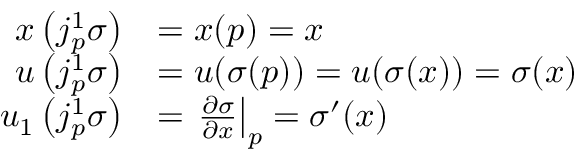<formula> <loc_0><loc_0><loc_500><loc_500>{ \begin{array} { r l } { x \left ( j _ { p } ^ { 1 } \sigma \right ) } & { = x ( p ) = x } \\ { u \left ( j _ { p } ^ { 1 } \sigma \right ) } & { = u ( \sigma ( p ) ) = u ( \sigma ( x ) ) = \sigma ( x ) } \\ { u _ { 1 } \left ( j _ { p } ^ { 1 } \sigma \right ) } & { = { \frac { \partial \sigma } { \partial x } } \right | _ { p } = \sigma ^ { \prime } ( x ) } \end{array} }</formula> 